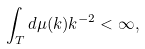Convert formula to latex. <formula><loc_0><loc_0><loc_500><loc_500>\int _ { T } d \mu ( k ) k ^ { - 2 } < \infty ,</formula> 